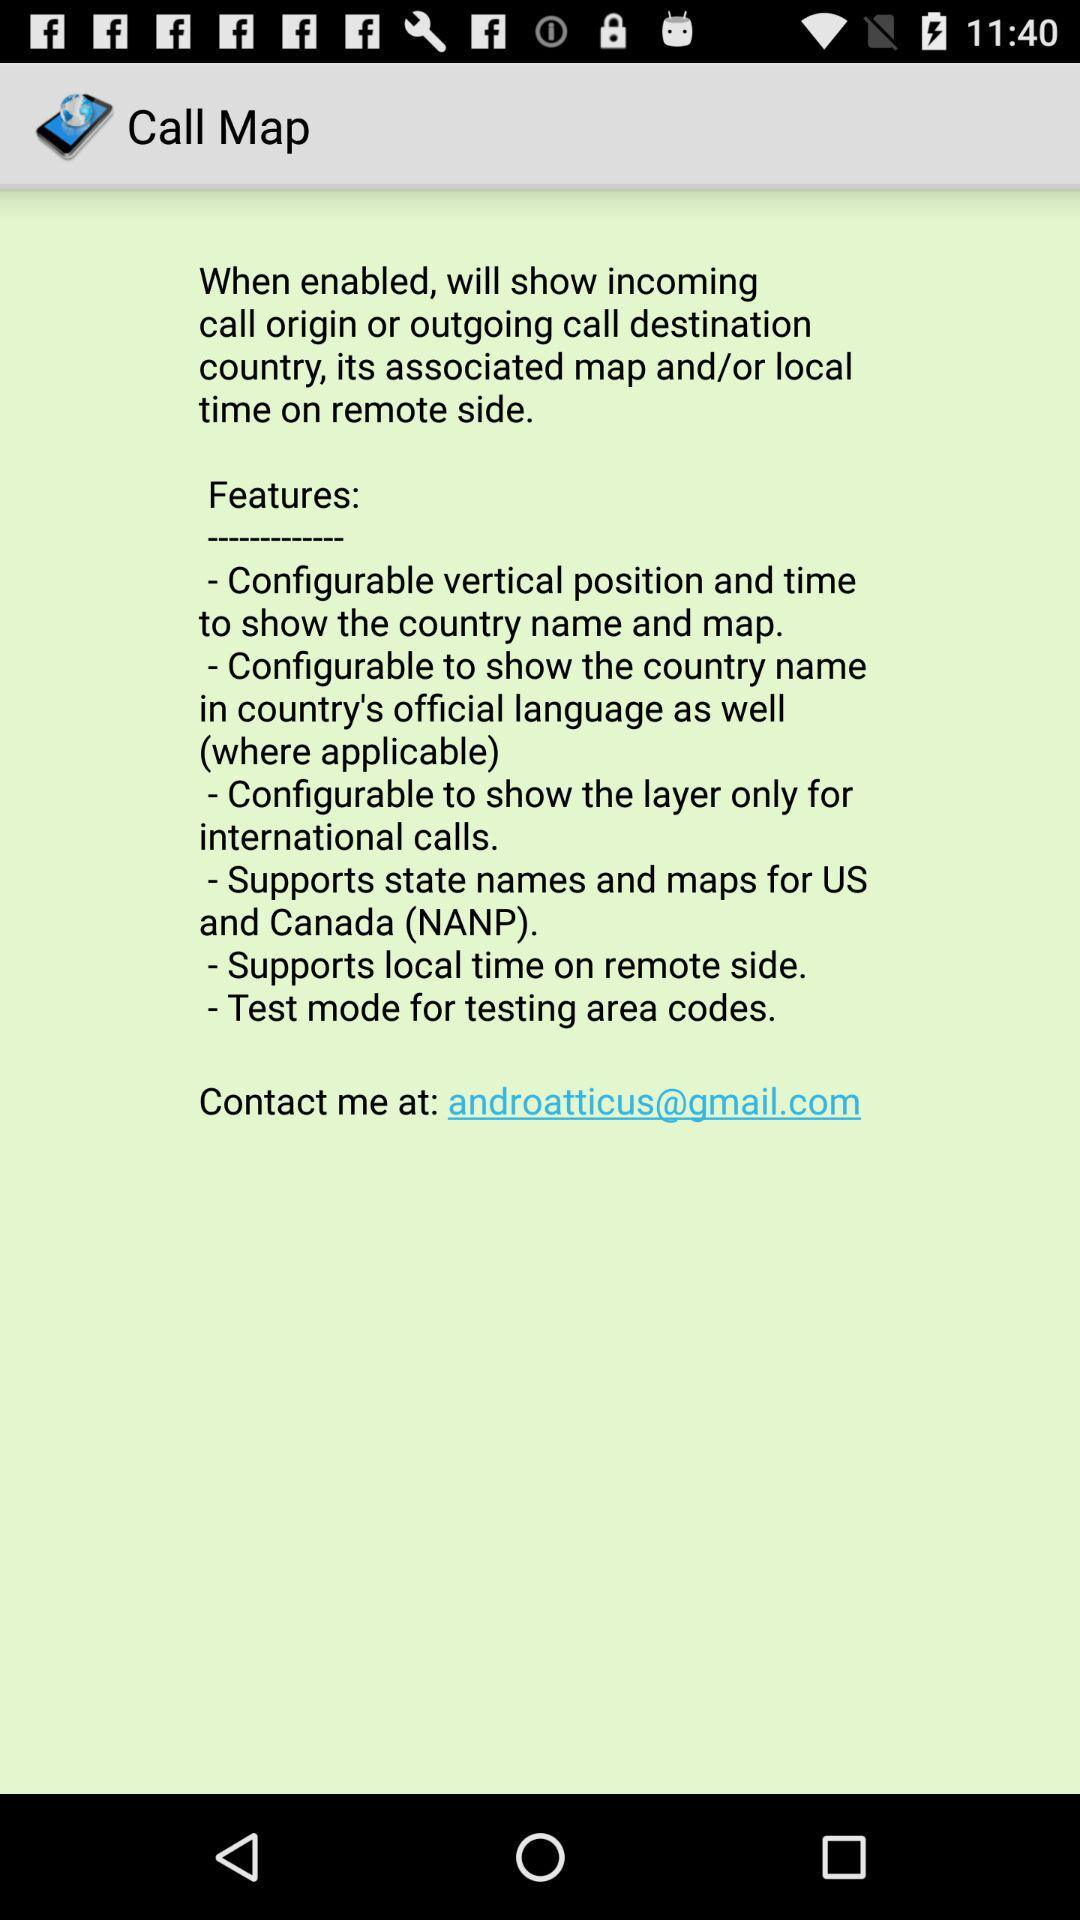What is the contact email address? The contact email address is androatticus@gmail.com. 